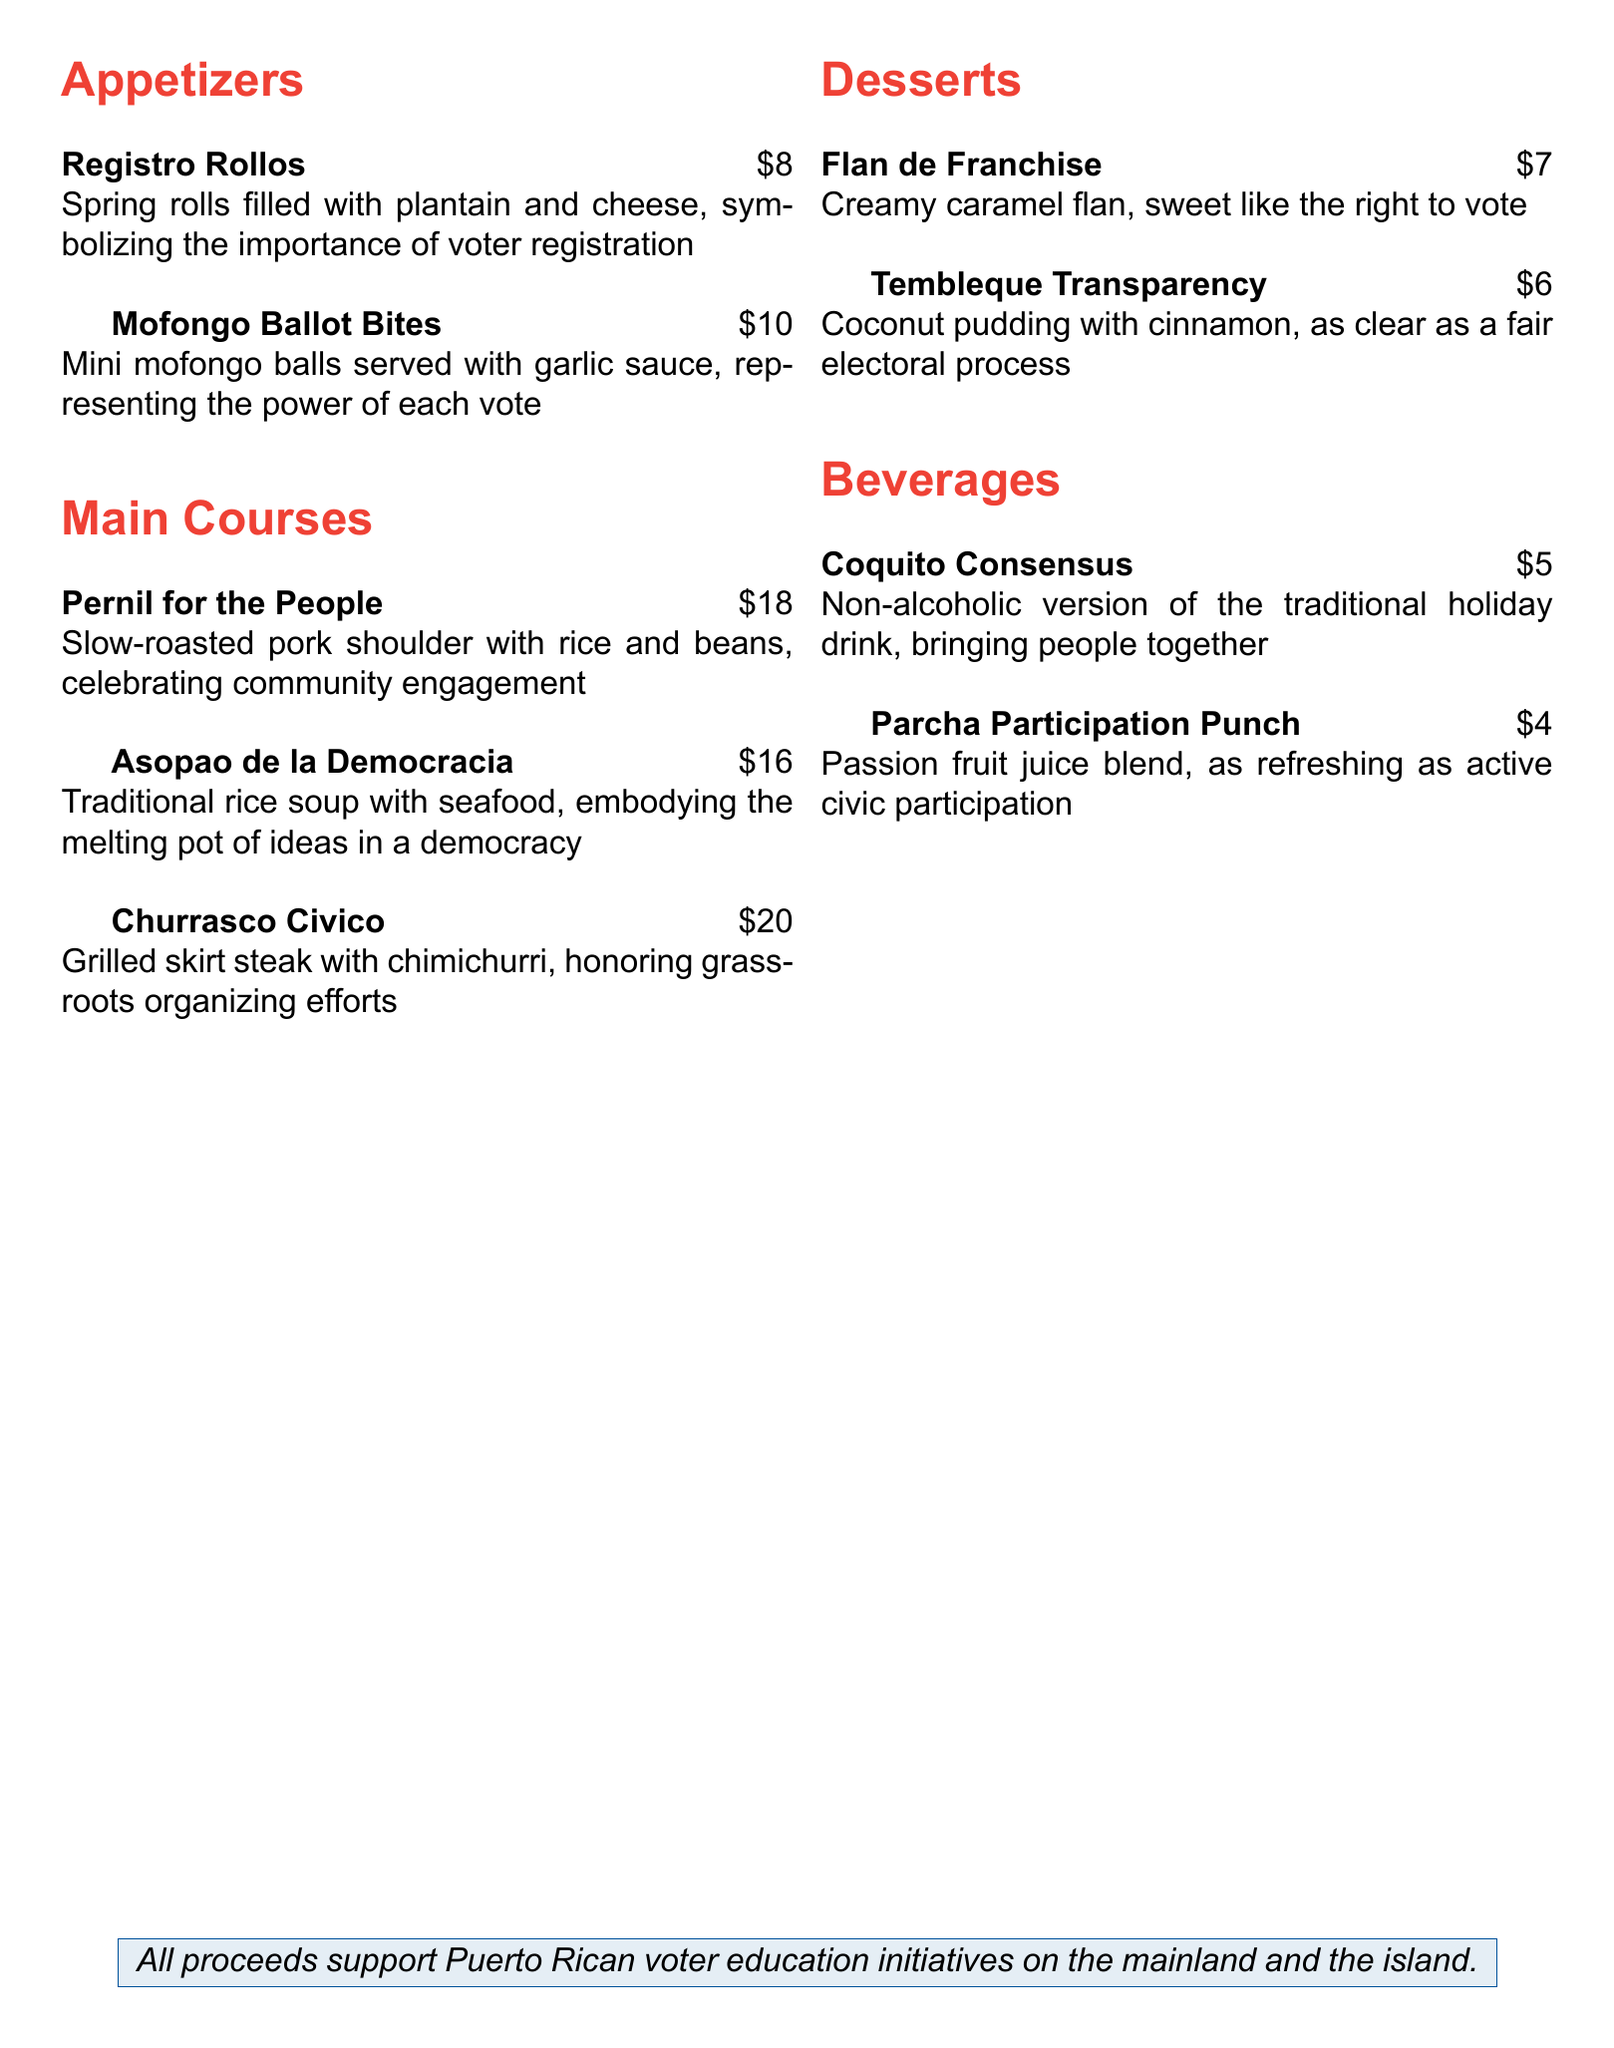What is the name of the event? The event is titled "Vota Con Sabor."
Answer: Vota Con Sabor What is the price of the Mofongo Ballot Bites? The Mofongo Ballot Bites are listed at a price of $10.
Answer: $10 Which dish represents voter registration? The dish that symbolizes voter registration is the Registro Rollos.
Answer: Registro Rollos What is the theme of the event? The theme of the event is "Savor Democracy, One Bite at a Time."
Answer: Savor Democracy, One Bite at a Time How much does the Pernil for the People cost? The Pernil for the People is priced at $18.
Answer: $18 What dessert symbolizes the right to vote? The dessert that symbolizes the right to vote is Flan de Franchise.
Answer: Flan de Franchise Which beverage is a non-alcoholic version of a traditional drink? The non-alcoholic beverage is Coquito Consensus.
Answer: Coquito Consensus What does the event support? The event supports Puerto Rican voter education initiatives.
Answer: Puerto Rican voter education initiatives What dish honors grassroots organizing efforts? The dish that honors grassroots organizing efforts is the Churrasco Civico.
Answer: Churrasco Civico 